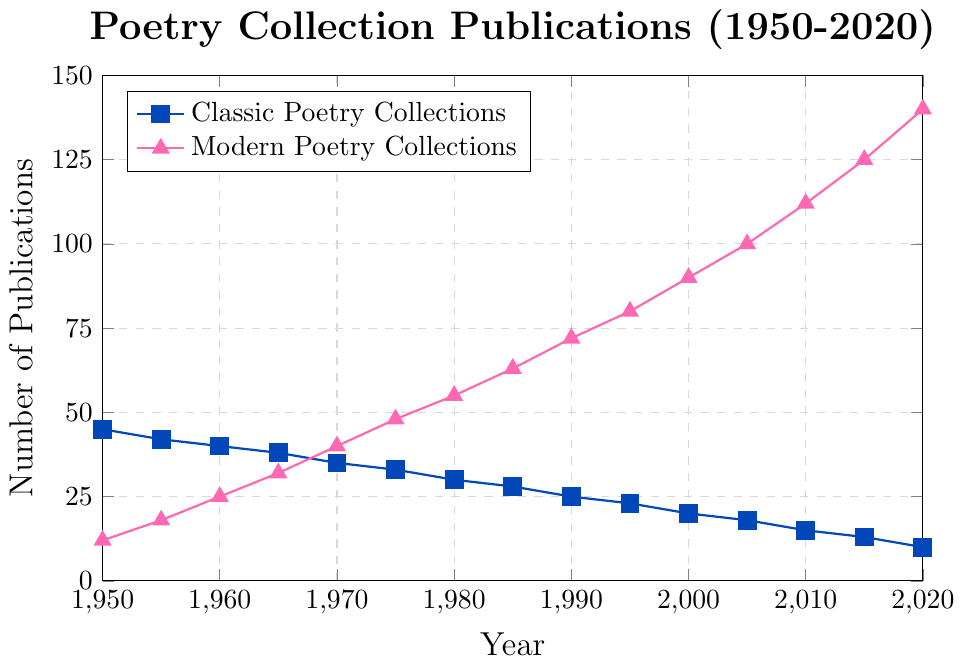What's the general trend for classic poetry collections between 1950 and 2020? By observing the plot, the number of publications for classic poetry collections consistently declines from 45 in 1950 to 10 in 2020.
Answer: Declining What year did modern poetry collections surpass classic poetry collections in number of publications? By examining the plot, modern poetry collections surpass classic poetry collections between the years of 1970 (classics at 35, moderns at 40) and 1975 (classics at 33, moderns at 48).
Answer: Around 1970 How many times higher was the publication of modern poetry collections compared to classic poetry collections in 2020? In 2020, modern poetry collections had 140 publications, and classic poetry collections had 10 publications. The ratio is 140/10, which simplifies to 14.
Answer: 14 times higher What is the deference in the number of publications between classic and modern poetry collections in 2000? In 2000, classic poetry collections had 20 publications whereas modern poetry collections had 90 publications. The difference is 90 - 20 = 70.
Answer: 70 How do the trends in publication numbers for classic and modern poetry collections from 1985 to 2005 compare? From the plot, from 1985 to 2005, classic poetry collections decrease from 28 to 18. Meanwhile, modern poetry collections increase from 63 to 100.
Answer: Classics decrease; Moderns increase In which decade did both classic and modern poetry collections experience the most significant changes in publication numbers? The steepest decline for classic poetry collections and the steepest increase for modern poetry collections both occur from the 1970s to the 1980s.
Answer: 1970s to 1980s 